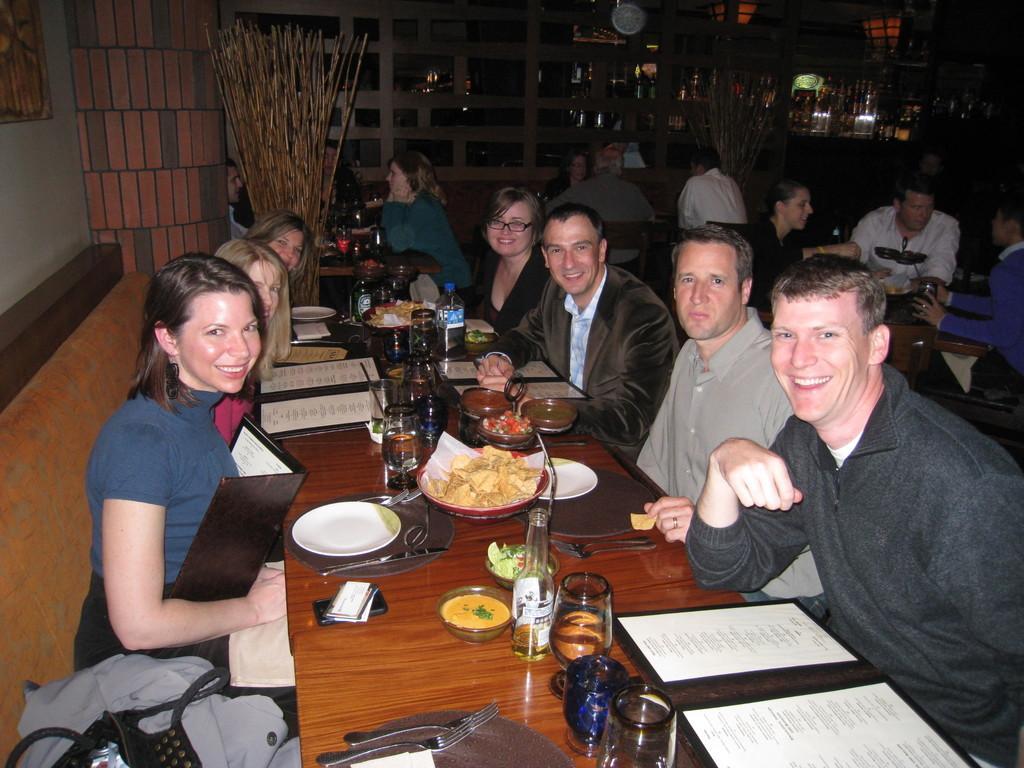In one or two sentences, can you explain what this image depicts? In this image, there are group of people sitting on the sofa facing each other at dining table. In the middle of the image, there is a table on which plates, bowls, glasses, bottle, mobile and soon is kept. In the background topmost, there is a wall clock which is white in color. In the left top most wall painting is visible. The picture looks as if it is taken inside the dining hall. 